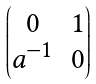Convert formula to latex. <formula><loc_0><loc_0><loc_500><loc_500>\begin{pmatrix} 0 & 1 \\ a ^ { - 1 } & 0 \end{pmatrix}</formula> 